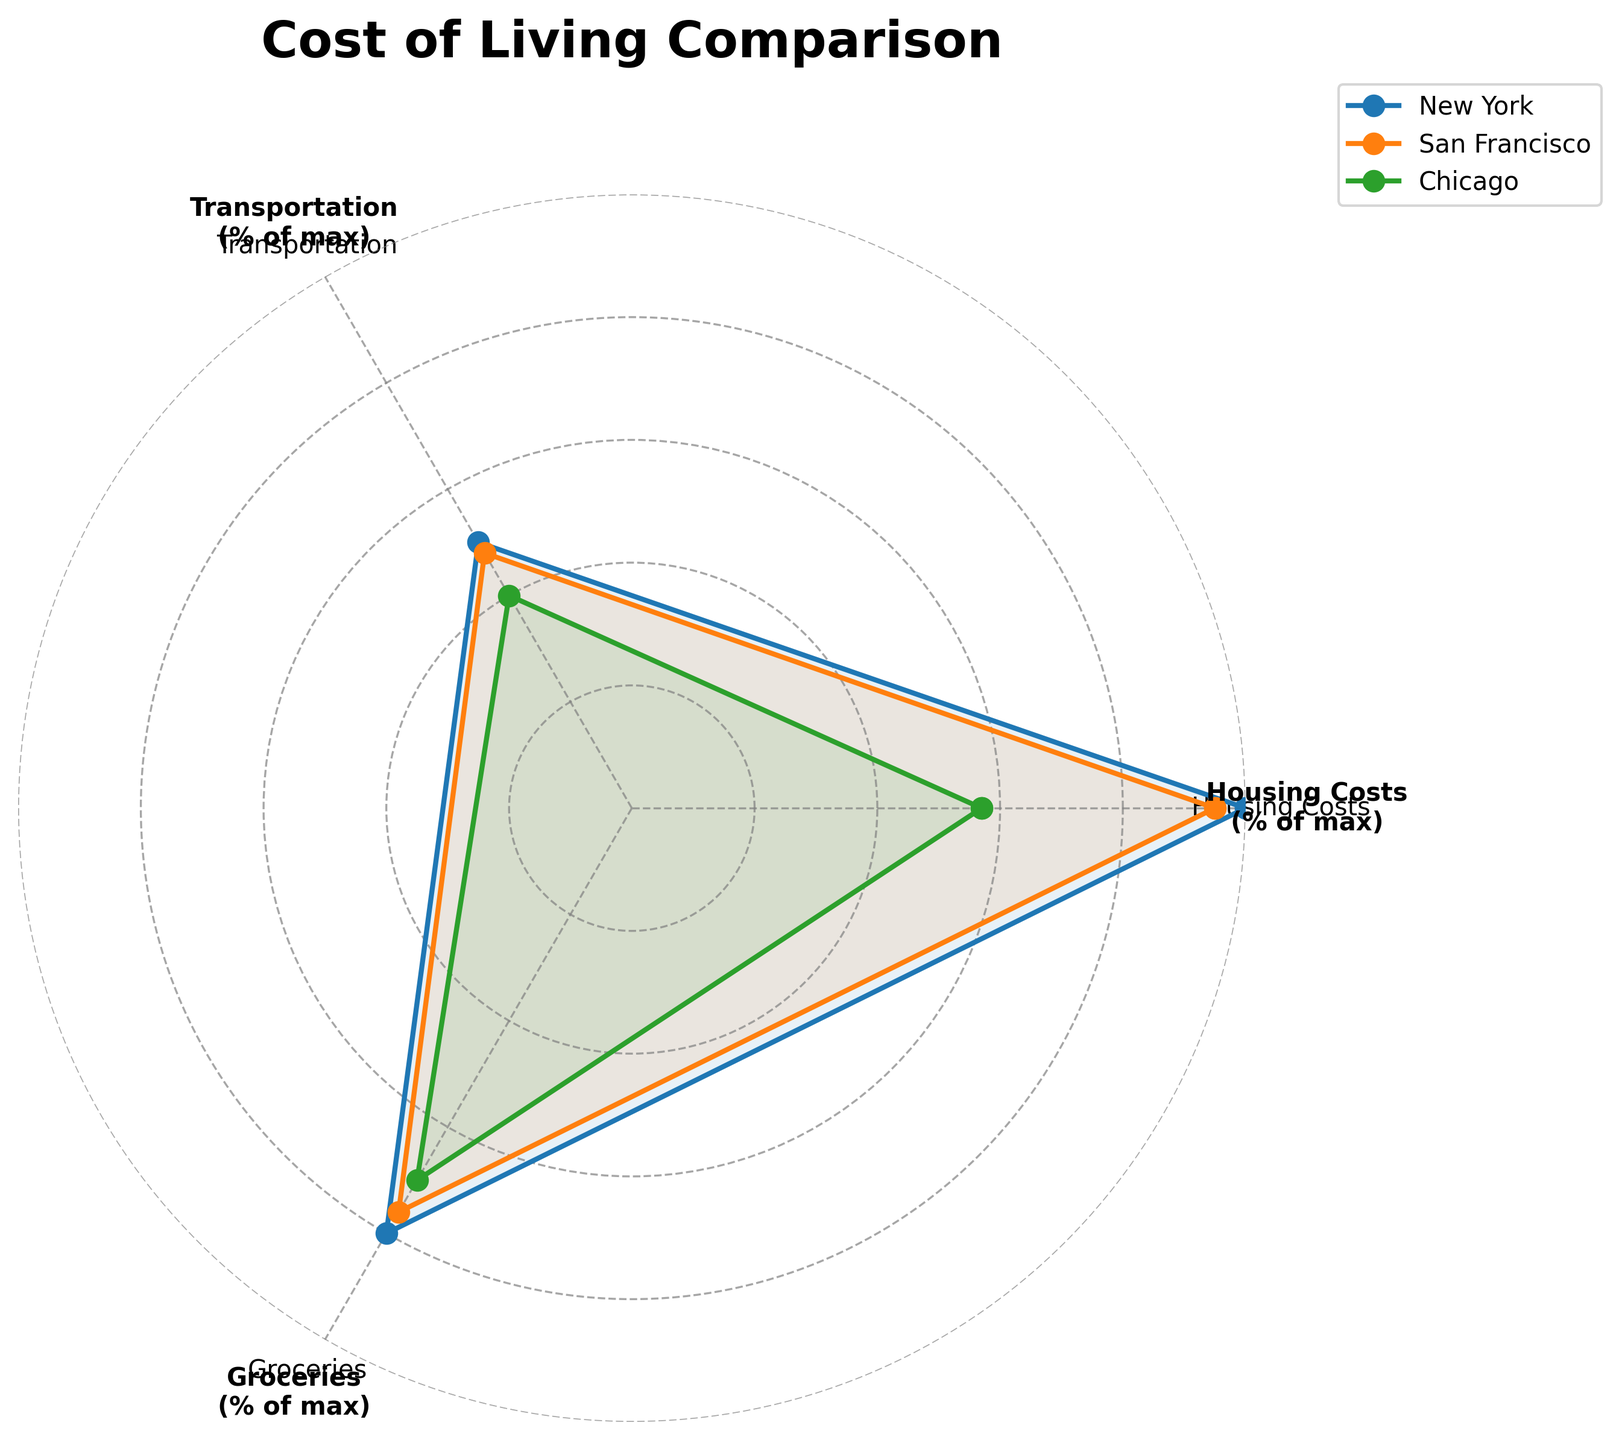What are the three categories compared in the radar chart? The three categories are directly labeled on the axes of the radar chart.
Answer: Housing Costs, Transportation, Groceries Which city has the highest percentage for Housing Costs? By observing the radar chart, the city with the furthest point from the origin for the Housing Costs axis will have the highest percentage.
Answer: New York Which city shows the lowest percentage in Groceries? The closest point to the origin on the Groceries axis indicates the lowest percentage.
Answer: Houston Compare the Housing Costs percentages between New York and San Francisco. The percentages can be read directly from the points on the Housing Costs axis. New York has 100%, and San Francisco has 95%.
Answer: New York > San Francisco Which category shows the least variation among the compared cities? Look for the category where the points for the cities are closest to each other on the radar chart.
Answer: Transportation Calculate the difference in Transportation percentage between Houston and Chicago. Compare the positions of Houston and Chicago on the Transportation axis. Houston has 37%, and Chicago has 40%. Subtract Houston's value from Chicago's value.
Answer: 3% Which city has the overall lowest percentages across all categories? Evaluate which city has the points closest to the origin across all categories.
Answer: Houston What is the average percentage for Groceries in the three cities shown in the chart? Read the Groceries percentages for New York (80%), San Francisco (76%), and Chicago (70%). Sum them and divide by the number of cities (3). Calculation: (80 + 76 + 70) / 3
Answer: 75.3% Is San Francisco’s Transportation percentage closer to New York or Chicago? New York's Transportation is 50% and Chicago's is 40%. San Francisco is at 48%. Compare these values.
Answer: Closer to New York 